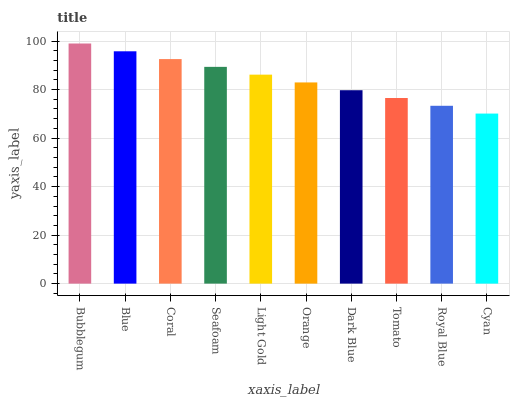Is Cyan the minimum?
Answer yes or no. Yes. Is Bubblegum the maximum?
Answer yes or no. Yes. Is Blue the minimum?
Answer yes or no. No. Is Blue the maximum?
Answer yes or no. No. Is Bubblegum greater than Blue?
Answer yes or no. Yes. Is Blue less than Bubblegum?
Answer yes or no. Yes. Is Blue greater than Bubblegum?
Answer yes or no. No. Is Bubblegum less than Blue?
Answer yes or no. No. Is Light Gold the high median?
Answer yes or no. Yes. Is Orange the low median?
Answer yes or no. Yes. Is Seafoam the high median?
Answer yes or no. No. Is Coral the low median?
Answer yes or no. No. 